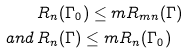Convert formula to latex. <formula><loc_0><loc_0><loc_500><loc_500>& R _ { n } ( \Gamma _ { 0 } ) \leq m R _ { m n } ( \Gamma ) \\ a n d \, & R _ { n } ( \Gamma ) \leq m R _ { n } ( \Gamma _ { 0 } )</formula> 